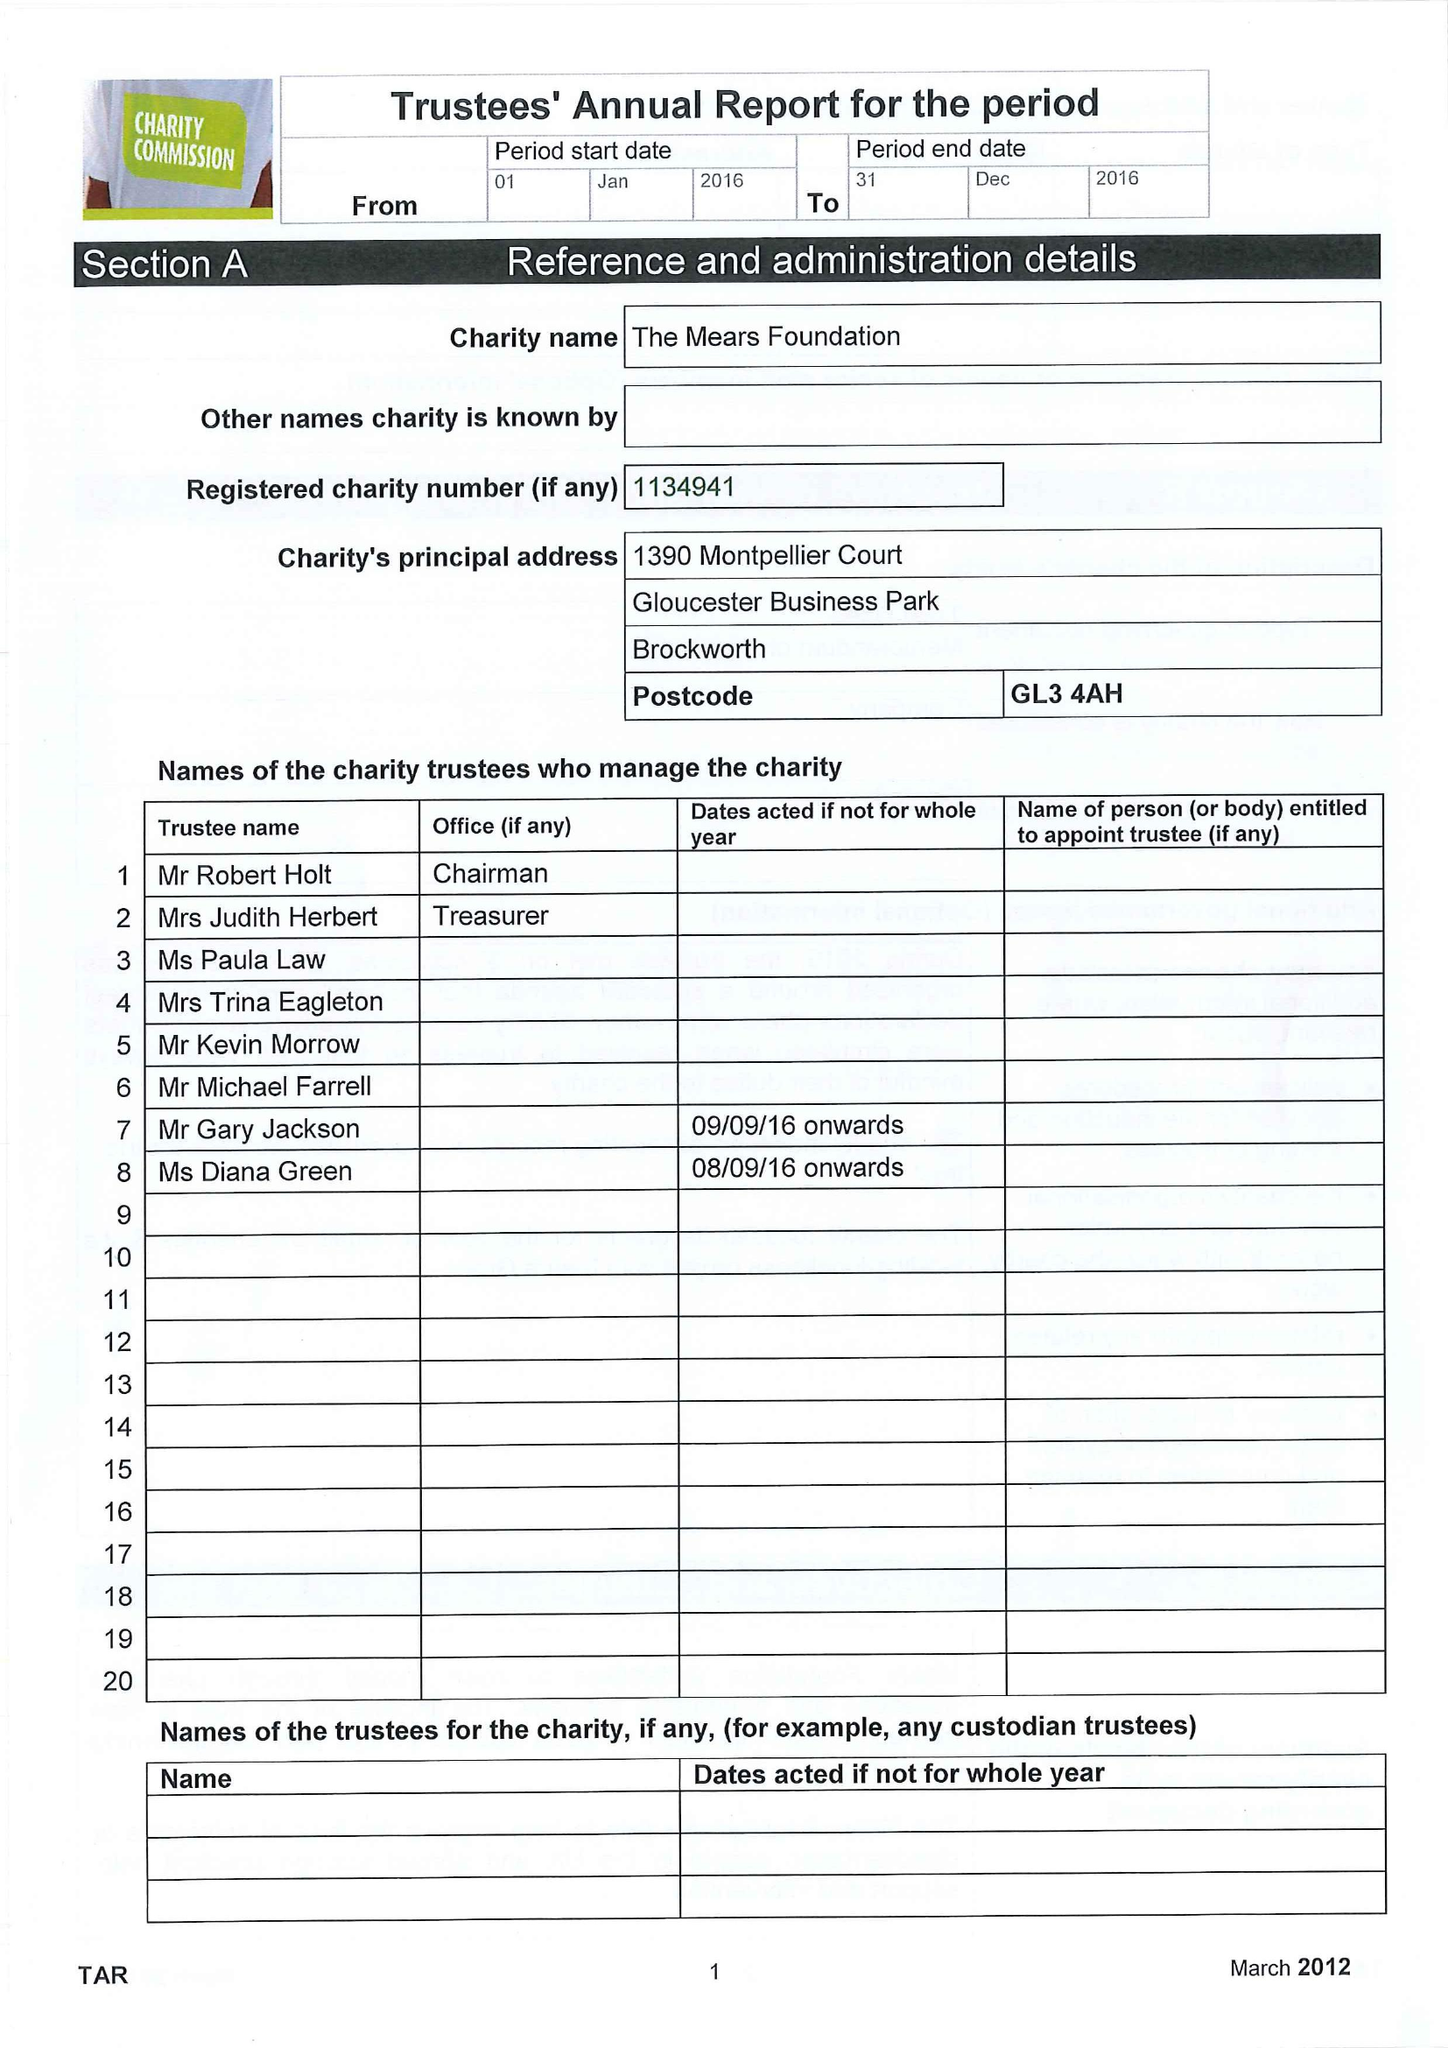What is the value for the address__postcode?
Answer the question using a single word or phrase. GL3 4AH 